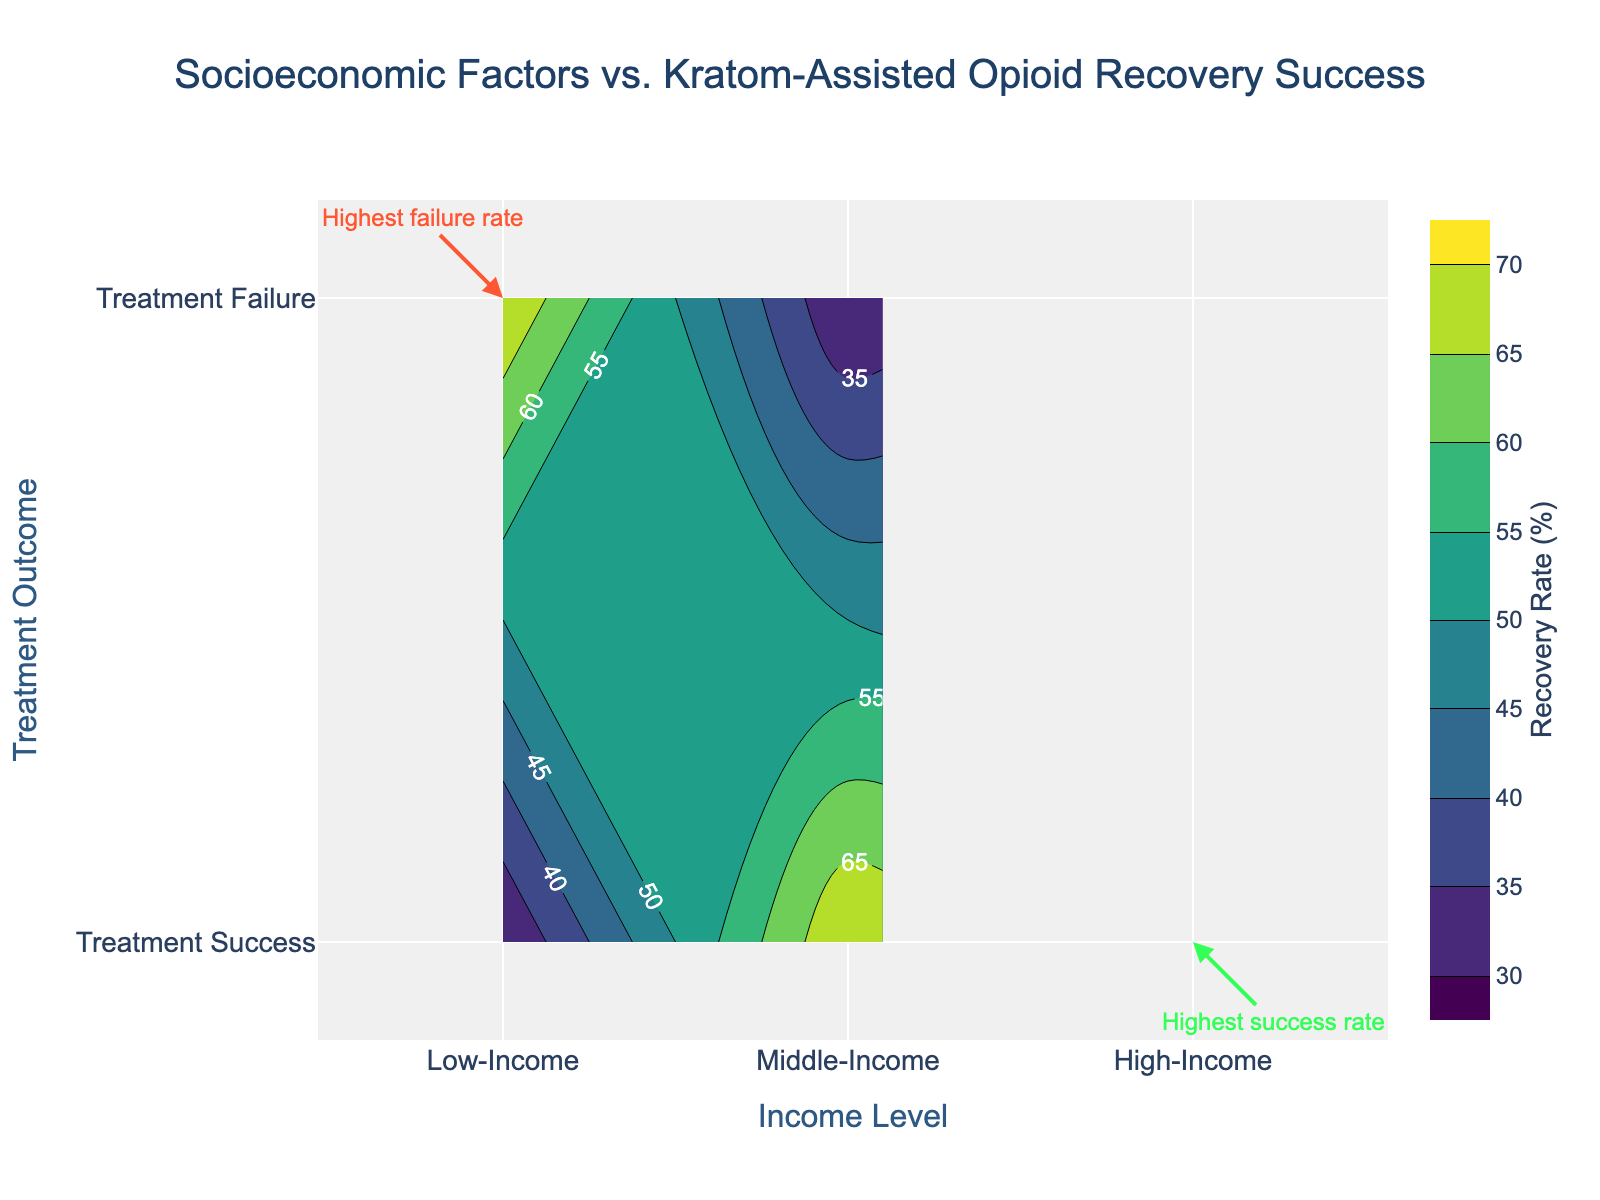What is the title of the figure? The title is typically found at the top of the chart and is usually the largest text. In this figure, the title reads "Socioeconomic Factors vs. Kratom-Assisted Opioid Recovery Success".
Answer: Socioeconomic Factors vs. Kratom-Assisted Opioid Recovery Success What does the x-axis represent in the figure? The labels on the x-axis indicate what is being measured along the horizontal direction of the plot. In this case, the x-axis is labeled "Income Level", showcasing various socioeconomic strata: Low-Income, Middle-Income, and High-Income.
Answer: Income Level What does the y-axis represent in the figure? The y-axis usually tells us what is being measured vertically. For this figure, the y-axis is labeled "Treatment Outcome", indicating the different results from the treatment programs categorized as Treatment Success and Treatment Failure.
Answer: Treatment Outcome Which income level has the highest treatment success rate? By observing the contour density and annotations, we see that High-Income has a contour plot labeled "Highest success rate", which signifies the highest treatment success rate among the income levels.
Answer: High-Income Which socioeconomic group has the highest treatment failure rate? From the annotations and density contours, the label "Highest failure rate" is closest to the Low-Income group under the Treatment Failure category, indicating that this group has the highest failure rate.
Answer: Low-Income What is the range of recovery rates depicted in the color bar? The color bar to the right of the figure indicates the range of values represented by the contours’ various colors. In this figure, it starts from 30% and ends at 70%, showing the range of recovery rates.
Answer: 30% to 70% By how much does the treatment success rate differ between Low-Income and High-Income groups? According to the contours and their corresponding rates, the success rate for Low-Income is around 30%, while for High-Income, it is about 70%. The difference is 70% - 30%.
Answer: 40% What contour color represents the 50% recovery rate? The data color scheme used can be seen on the color bar. By referencing the color bar, we can deduce that the color associated with the 50% recovery rate is a medium shade of the chosen color scheme, Viridis.
Answer: A medium shade of Viridis In which income level does the treatment failure rate appear higher than the treatment success rate? By comparing the contour densities, in the Low-Income group, the contour density for Treatment Failure appears much higher than that for Treatment Success, signifying a higher failure rate compared to the success rate.
Answer: Low-Income 